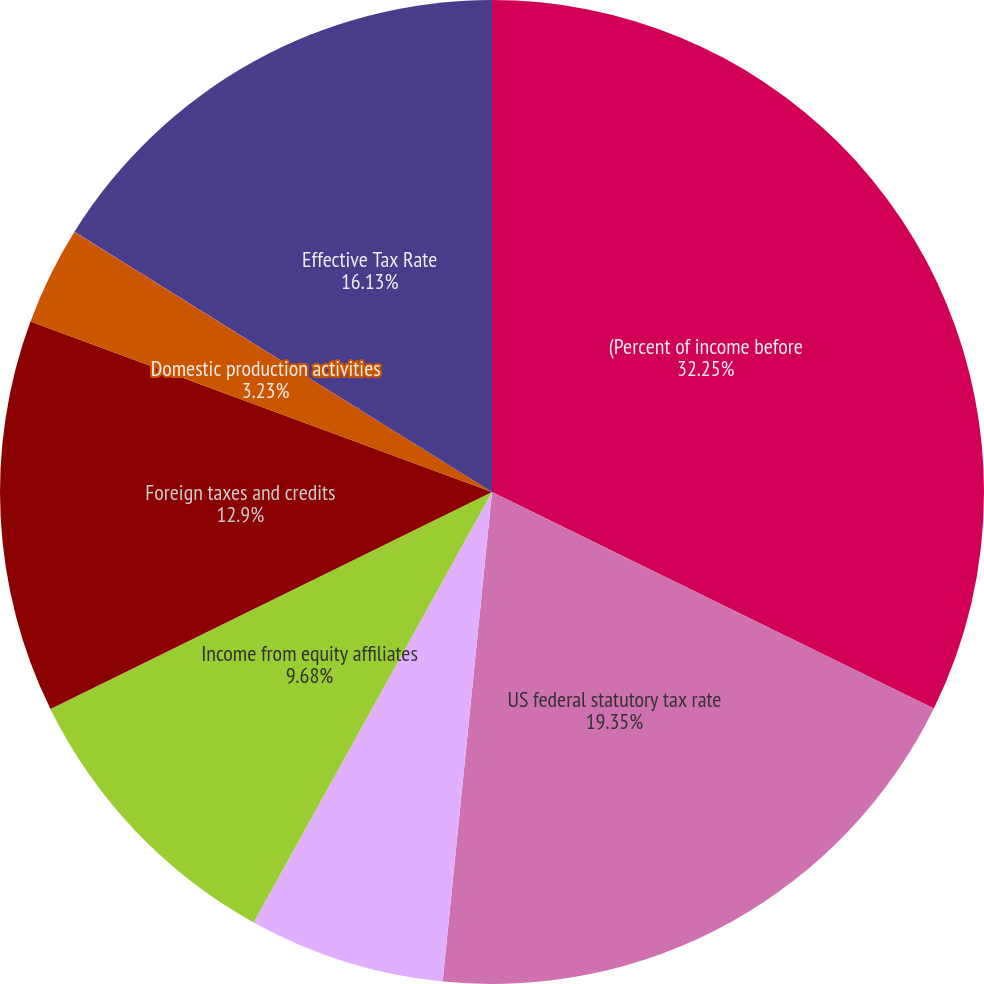<chart> <loc_0><loc_0><loc_500><loc_500><pie_chart><fcel>(Percent of income before<fcel>US federal statutory tax rate<fcel>State taxes net of federal<fcel>Income from equity affiliates<fcel>Foreign taxes and credits<fcel>Domestic production activities<fcel>Other<fcel>Effective Tax Rate<nl><fcel>32.25%<fcel>19.35%<fcel>6.45%<fcel>9.68%<fcel>12.9%<fcel>3.23%<fcel>0.01%<fcel>16.13%<nl></chart> 